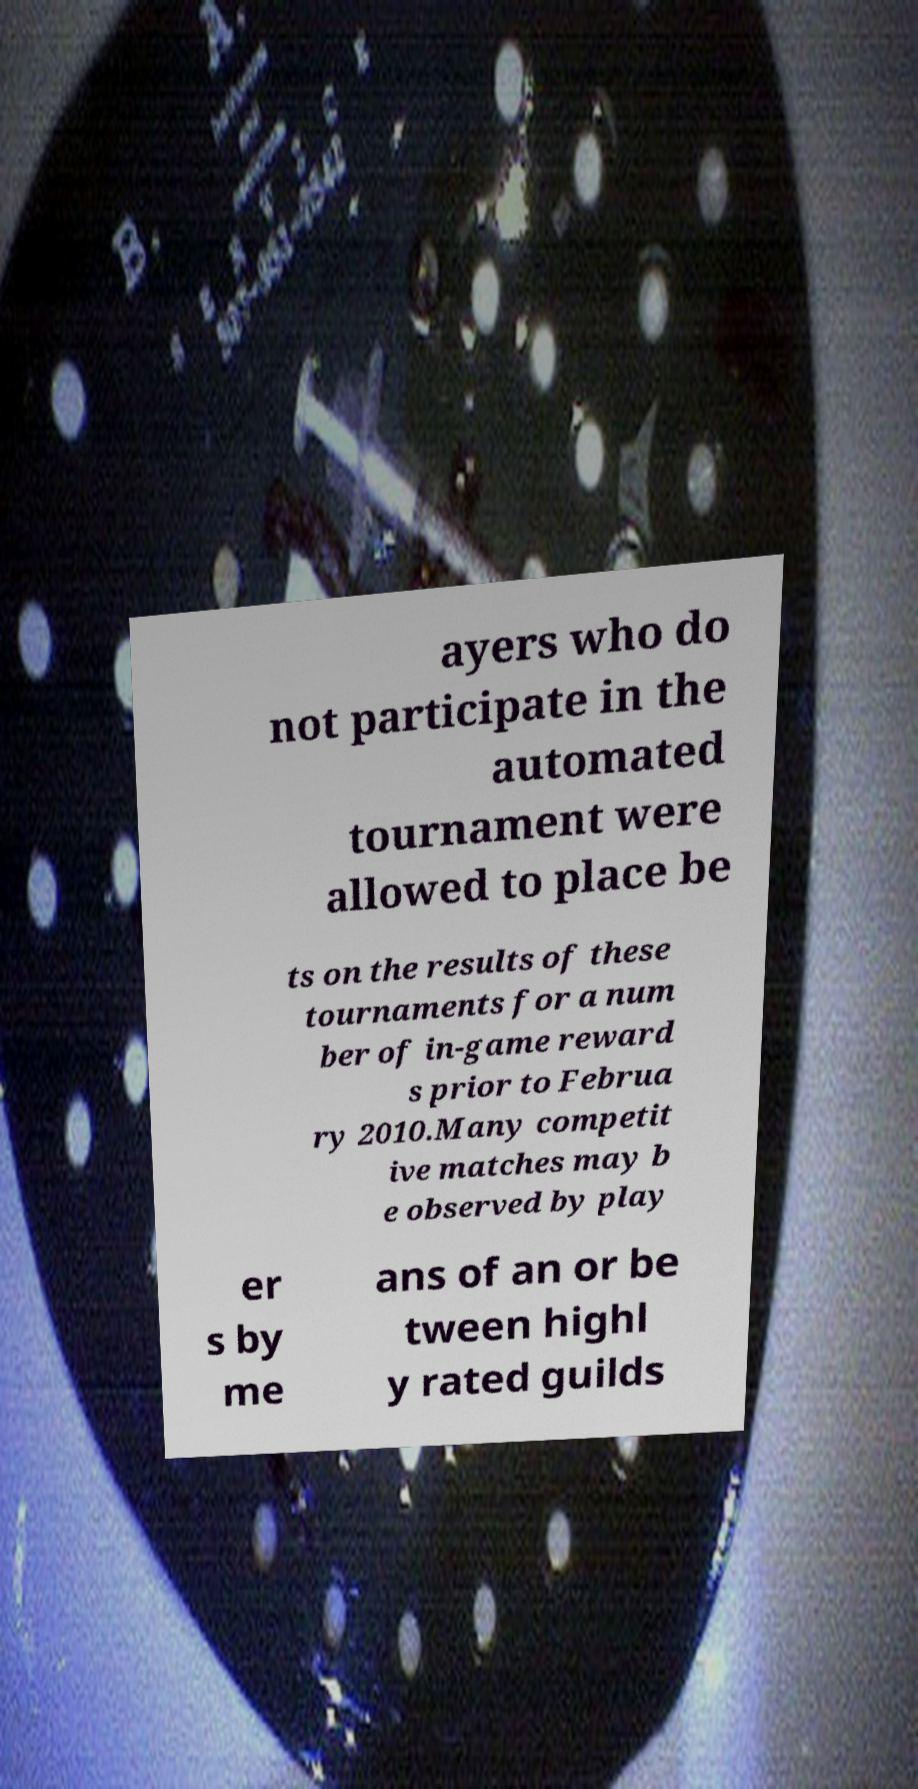Please identify and transcribe the text found in this image. ayers who do not participate in the automated tournament were allowed to place be ts on the results of these tournaments for a num ber of in-game reward s prior to Februa ry 2010.Many competit ive matches may b e observed by play er s by me ans of an or be tween highl y rated guilds 